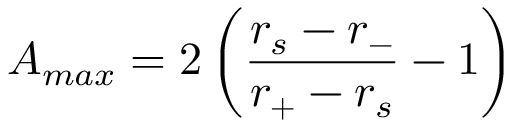Convert formula to latex. <formula><loc_0><loc_0><loc_500><loc_500>A _ { \max } = 2 \left ( \frac { r _ { s } - r _ { - } } { r _ { + } - r _ { s } } - 1 \right )</formula> 